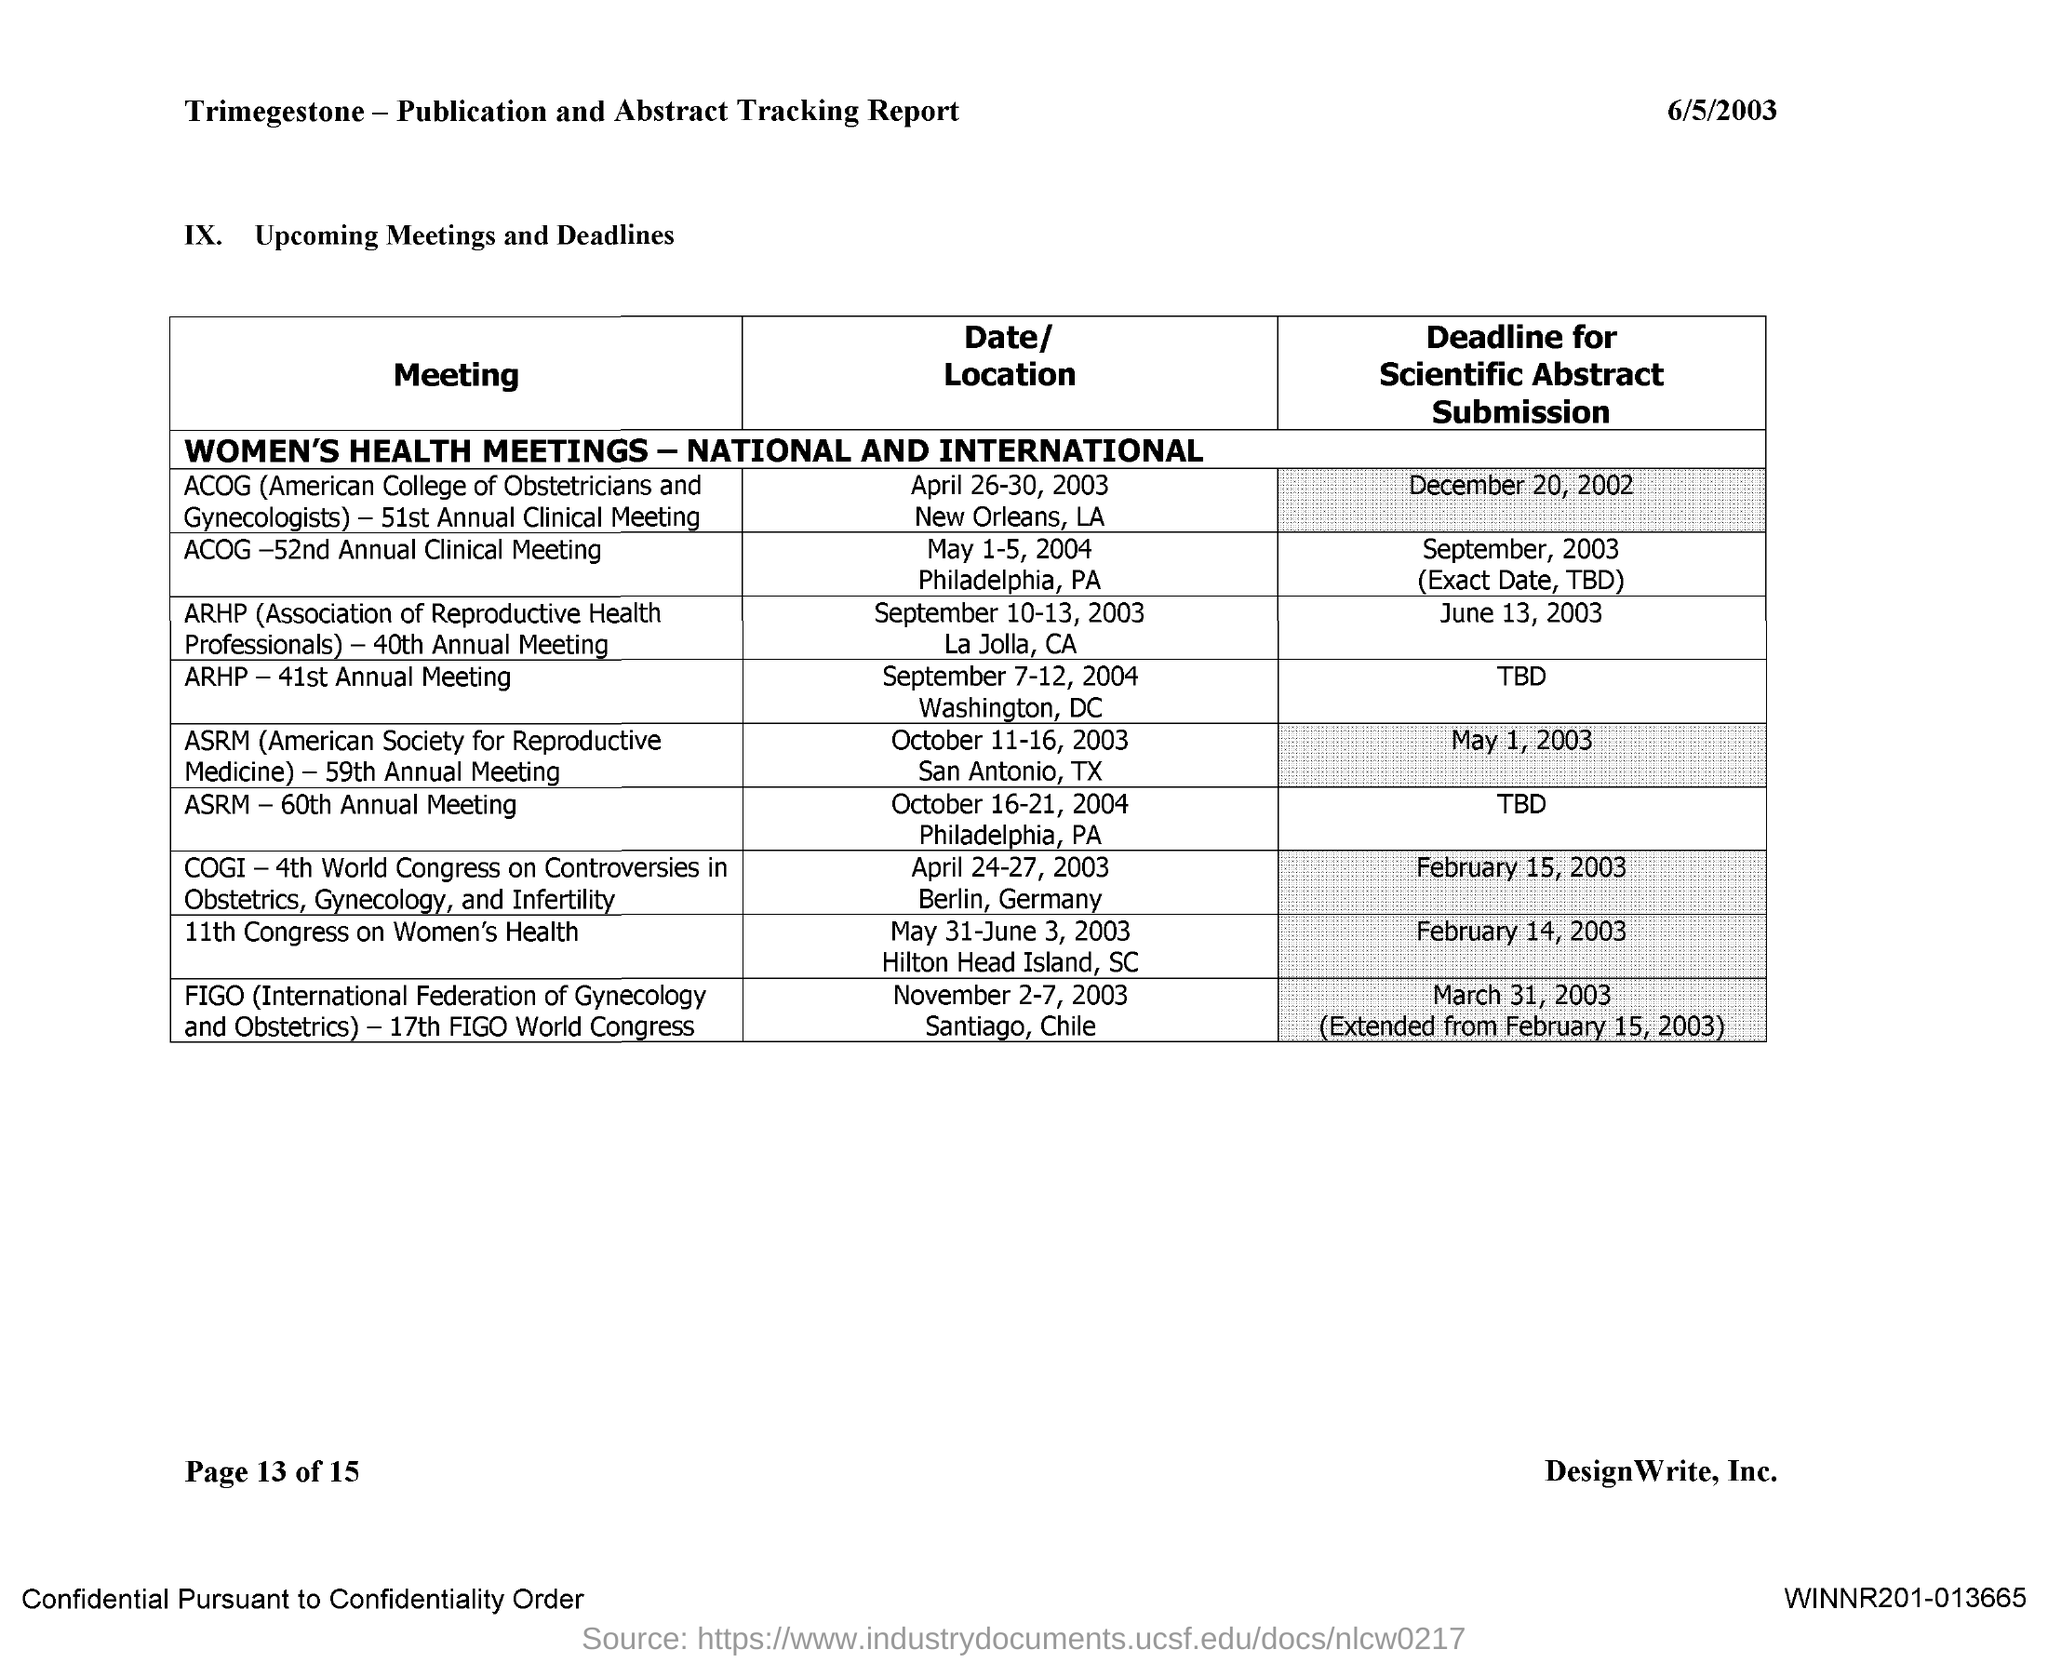Give some essential details in this illustration. The full form of ASRM is the American Society for Reproductive Medicine. 